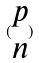<formula> <loc_0><loc_0><loc_500><loc_500>( \begin{matrix} p \\ n \end{matrix} )</formula> 